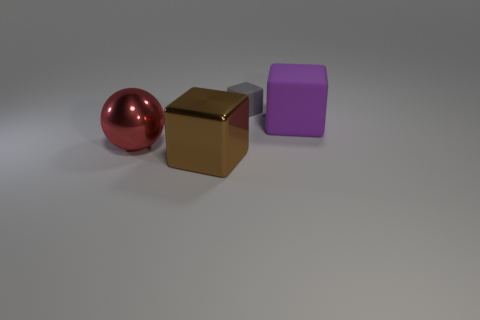There is a metal object that is in front of the big metallic ball that is left of the matte object left of the purple rubber object; what is its color?
Ensure brevity in your answer.  Brown. How many objects are both in front of the large red object and behind the large purple thing?
Offer a terse response. 0. There is a thing left of the big brown thing; is it the same color as the big block that is left of the large purple rubber cube?
Ensure brevity in your answer.  No. Are there any other things that are the same material as the brown object?
Offer a terse response. Yes. The other rubber object that is the same shape as the small rubber object is what size?
Provide a short and direct response. Large. Are there any large blocks in front of the large matte object?
Give a very brief answer. Yes. Are there an equal number of large blocks that are behind the gray matte thing and large green matte spheres?
Your answer should be very brief. Yes. Are there any big balls that are behind the matte cube that is behind the large object right of the gray matte block?
Give a very brief answer. No. What material is the large ball?
Ensure brevity in your answer.  Metal. How many other objects are the same shape as the gray object?
Provide a succinct answer. 2. 